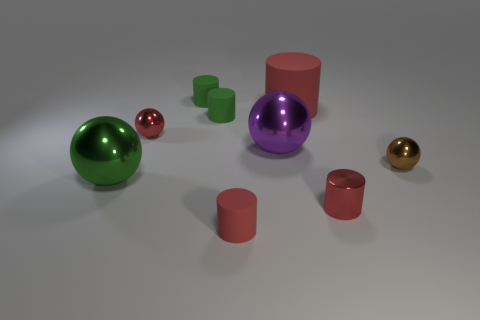Are there any red cubes that have the same material as the large purple object?
Your response must be concise. No. Do the large green ball and the purple ball have the same material?
Offer a terse response. Yes. What number of cubes are either brown metallic objects or metallic objects?
Offer a very short reply. 0. There is another big sphere that is the same material as the large purple sphere; what is its color?
Your answer should be very brief. Green. Are there fewer green matte cylinders than small brown objects?
Keep it short and to the point. No. Do the red thing that is in front of the metal cylinder and the tiny red object that is on the right side of the big purple ball have the same shape?
Provide a short and direct response. Yes. How many objects are either gray matte things or tiny things?
Your response must be concise. 6. There is another metallic sphere that is the same size as the purple sphere; what is its color?
Your response must be concise. Green. There is a sphere that is in front of the tiny brown object; what number of rubber cylinders are behind it?
Give a very brief answer. 3. How many green objects are both on the right side of the large green ball and in front of the large matte cylinder?
Ensure brevity in your answer.  1. 